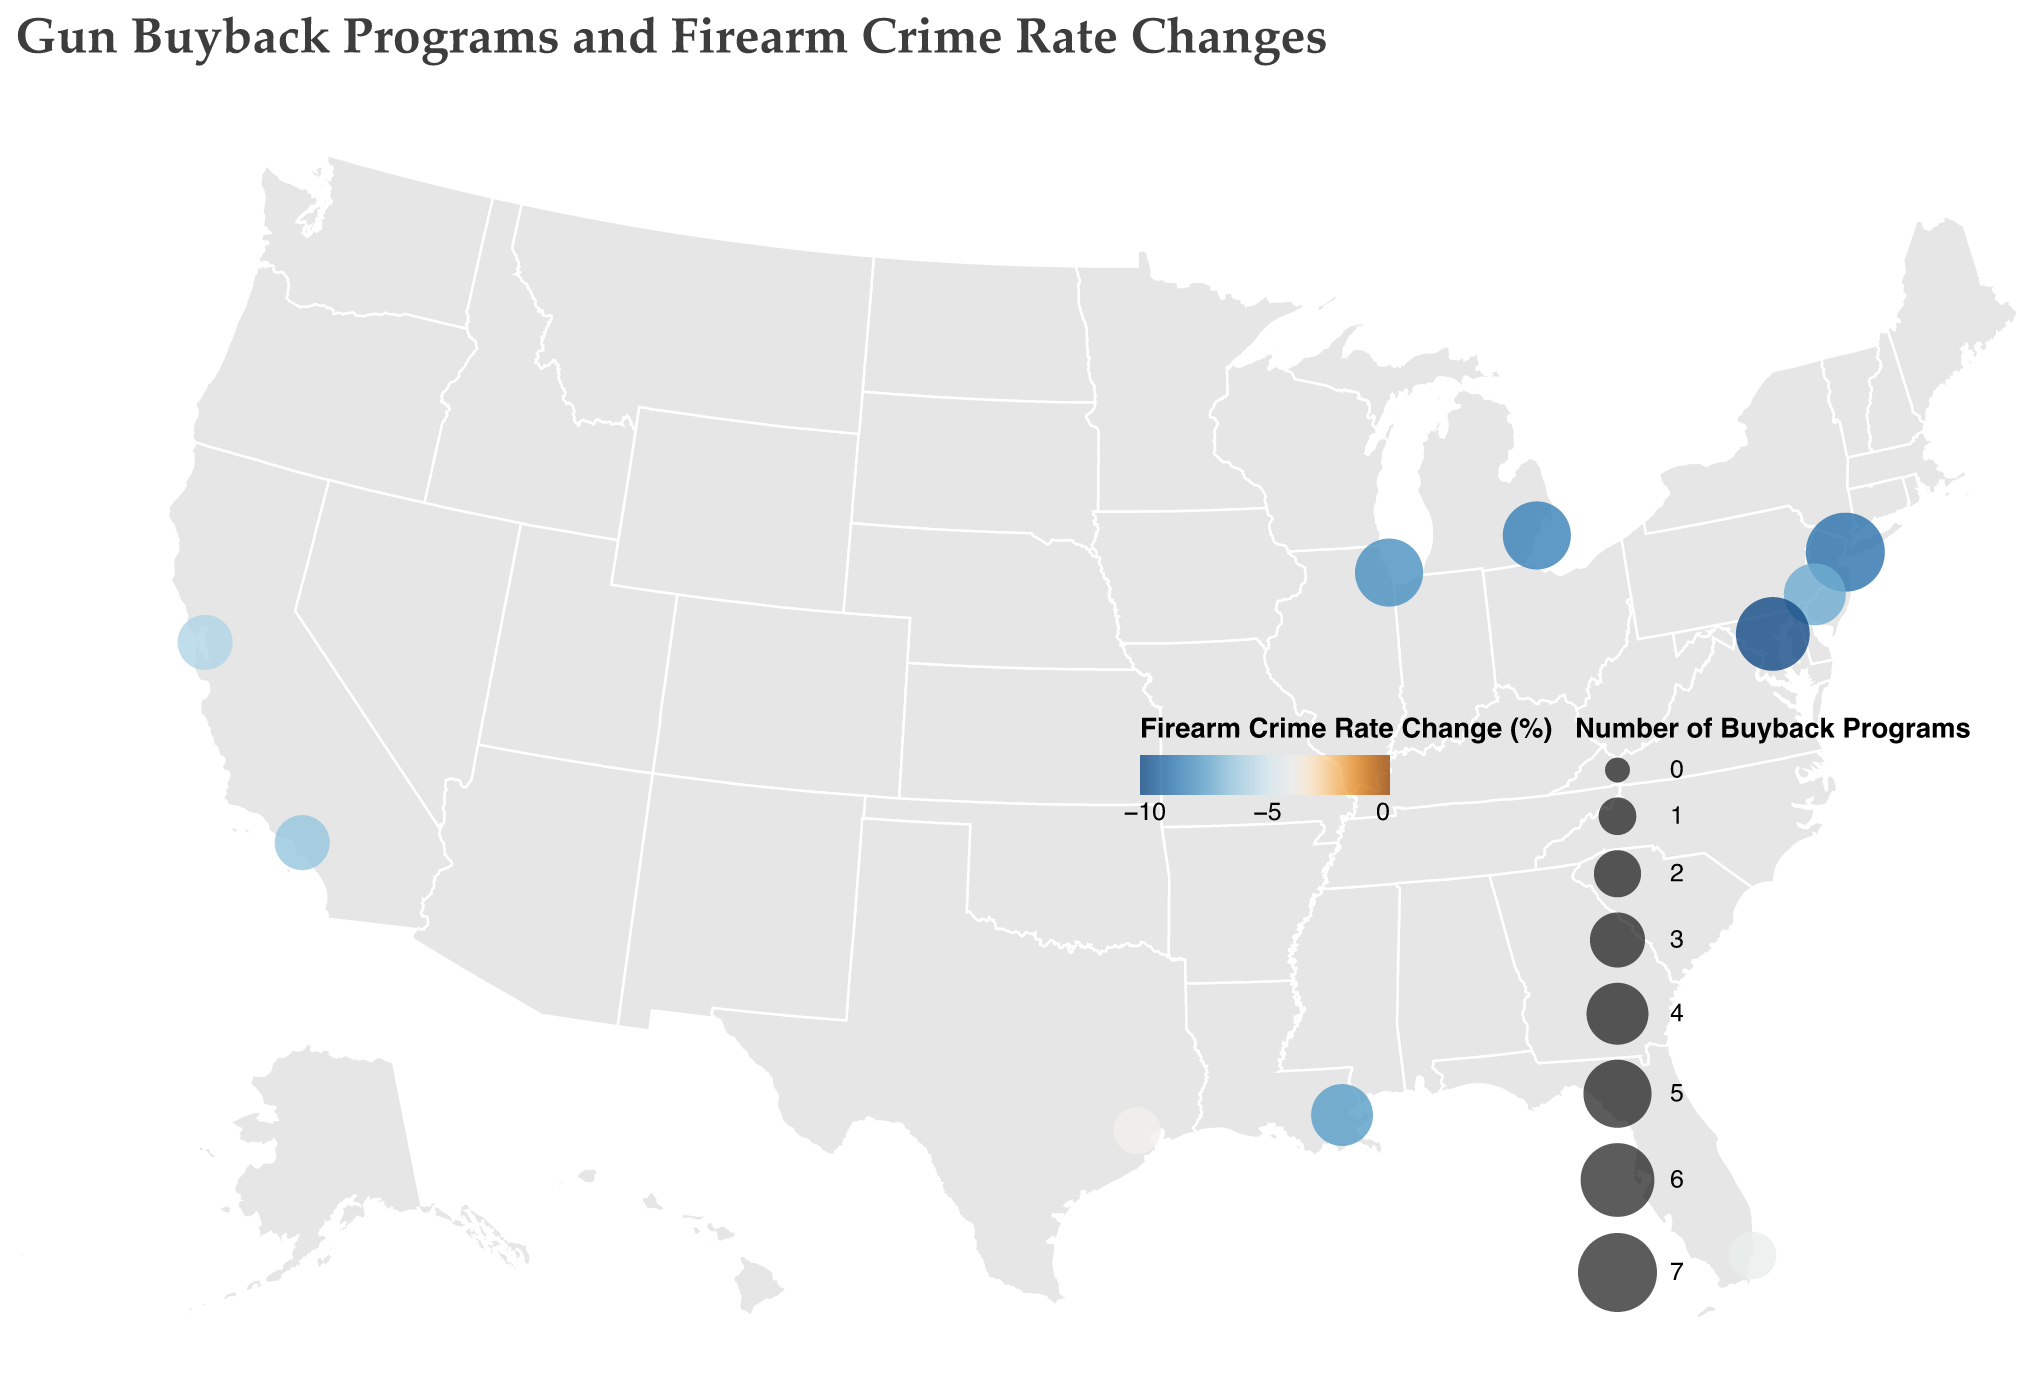What is the title of the figure? The title of a figure is usually located at the top and is meant to provide a summary of what the plot represents. In this case, we see that the title is "Gun Buyback Programs and Firearm Crime Rate Changes".
Answer: Gun Buyback Programs and Firearm Crime Rate Changes Which city has the highest number of gun buyback programs? The number of gun buyback programs is indicated by the size of the circles on the map. The tooltip information also shows Chicago with 7 buyback programs, the highest among all the cities.
Answer: New York City What is the firearm crime rate change in Baltimore? To find the firearm crime rate change in Baltimore, locate the circle representing Baltimore on the map and refer to the tooltip or legend. The data shows that Baltimore has a firearm crime rate change of -10.2%.
Answer: -10.2% Which city experienced the smallest decrease in firearm crime rates? By comparing the firearm crime rate change values for all cities, we see that Houston experienced the smallest decrease with a change of -3.8%.
Answer: Houston How many gun buyback programs were conducted in Oakland, California? The size of the circles on the map indicates the number of buyback programs. According to the map, Oakland had 3 buyback programs.
Answer: 3 Which city has decreased firearm crime rates the most, and what is the percentage? Compare the "Firearm Crime Rate Change" values for all cities. Baltimore has the highest decrease with a rate of -10.2%.
Answer: Baltimore, -10.2% Does a higher number of buyback programs generally correlate with a greater decrease in firearm crime rates based on the visual data? Look at the relationship between the size of the circles (number of buyback programs) and the color shading (firearm crime rate change). Generally, larger circles (more buyback programs) tend to have darker shades (greater decreases), indicating a correlation.
Answer: Yes What is the total number of buyback programs conducted in all the cities combined? Add up the number of buyback programs for all the cities: 5 (Chicago) + 3 (Los Angeles) + 7 (New York City) + 2 (Houston) + 4 (Philadelphia) + 6 (Baltimore) + 5 (Detroit) + 3 (Oakland) + 2 (Miami) + 4 (New Orleans) = 41.
Answer: 41 How does the firearm crime rate change in New Orleans compare to that of Philadelphia? Compare the firearm crime rate change values for New Orleans and Philadelphia. New Orleans had a change of -7.8%, while Philadelphia had a change of -7.3%.
Answer: New Orleans had a slightly greater decrease (-7.8%) compared to Philadelphia (-7.3%) Which two cities in California are included in the plot, and what are their firearm crime rate changes? Identify the cities in California based on the tooltip data. Los Angeles has a firearm crime rate change of -6.5%, and Oakland has a change of -5.9%.
Answer: Los Angeles (-6.5%) and Oakland (-5.9%) 